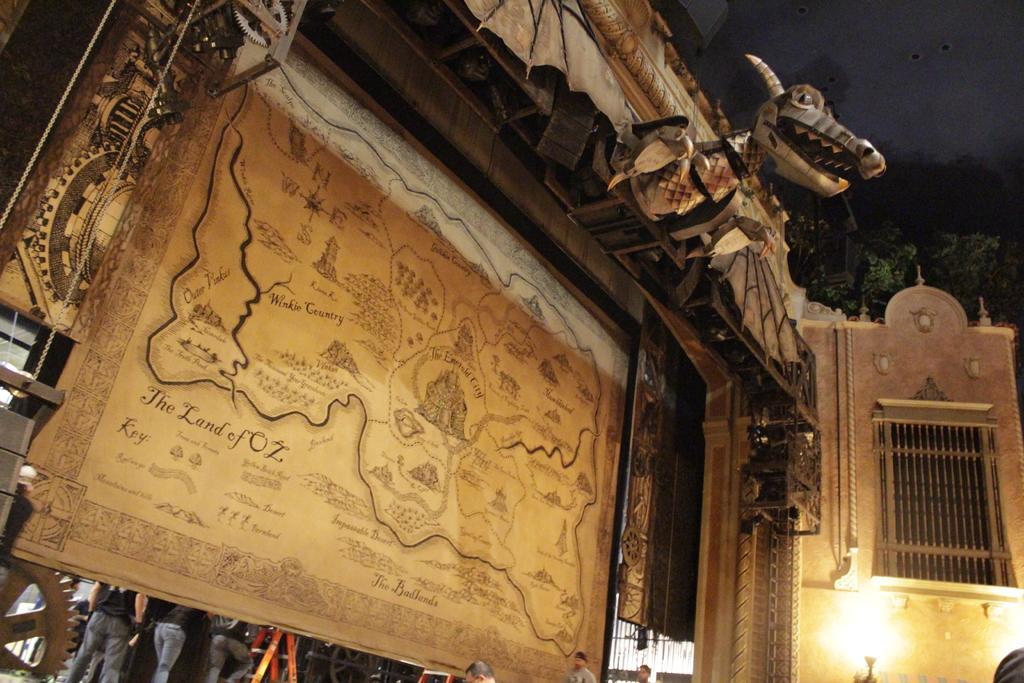In one or two sentences, can you explain what this image depicts? In this we can see there is a wooden block with map and some map on it, under that there are so many people standing. 